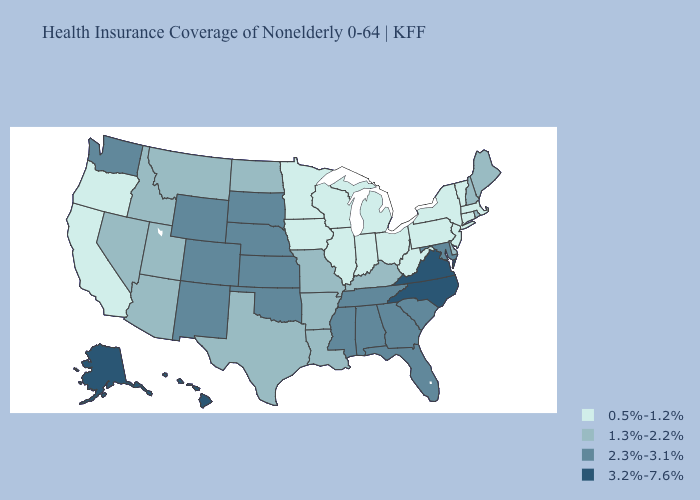What is the highest value in states that border Florida?
Concise answer only. 2.3%-3.1%. What is the lowest value in the MidWest?
Give a very brief answer. 0.5%-1.2%. What is the lowest value in states that border Kansas?
Quick response, please. 1.3%-2.2%. What is the highest value in the West ?
Keep it brief. 3.2%-7.6%. Name the states that have a value in the range 3.2%-7.6%?
Quick response, please. Alaska, Hawaii, North Carolina, Virginia. Which states have the lowest value in the South?
Write a very short answer. West Virginia. How many symbols are there in the legend?
Answer briefly. 4. Does North Carolina have the highest value in the USA?
Quick response, please. Yes. Name the states that have a value in the range 3.2%-7.6%?
Keep it brief. Alaska, Hawaii, North Carolina, Virginia. What is the value of Indiana?
Be succinct. 0.5%-1.2%. Does Idaho have the lowest value in the USA?
Give a very brief answer. No. What is the lowest value in the USA?
Give a very brief answer. 0.5%-1.2%. Which states hav the highest value in the South?
Give a very brief answer. North Carolina, Virginia. What is the value of New York?
Be succinct. 0.5%-1.2%. Does the map have missing data?
Short answer required. No. 